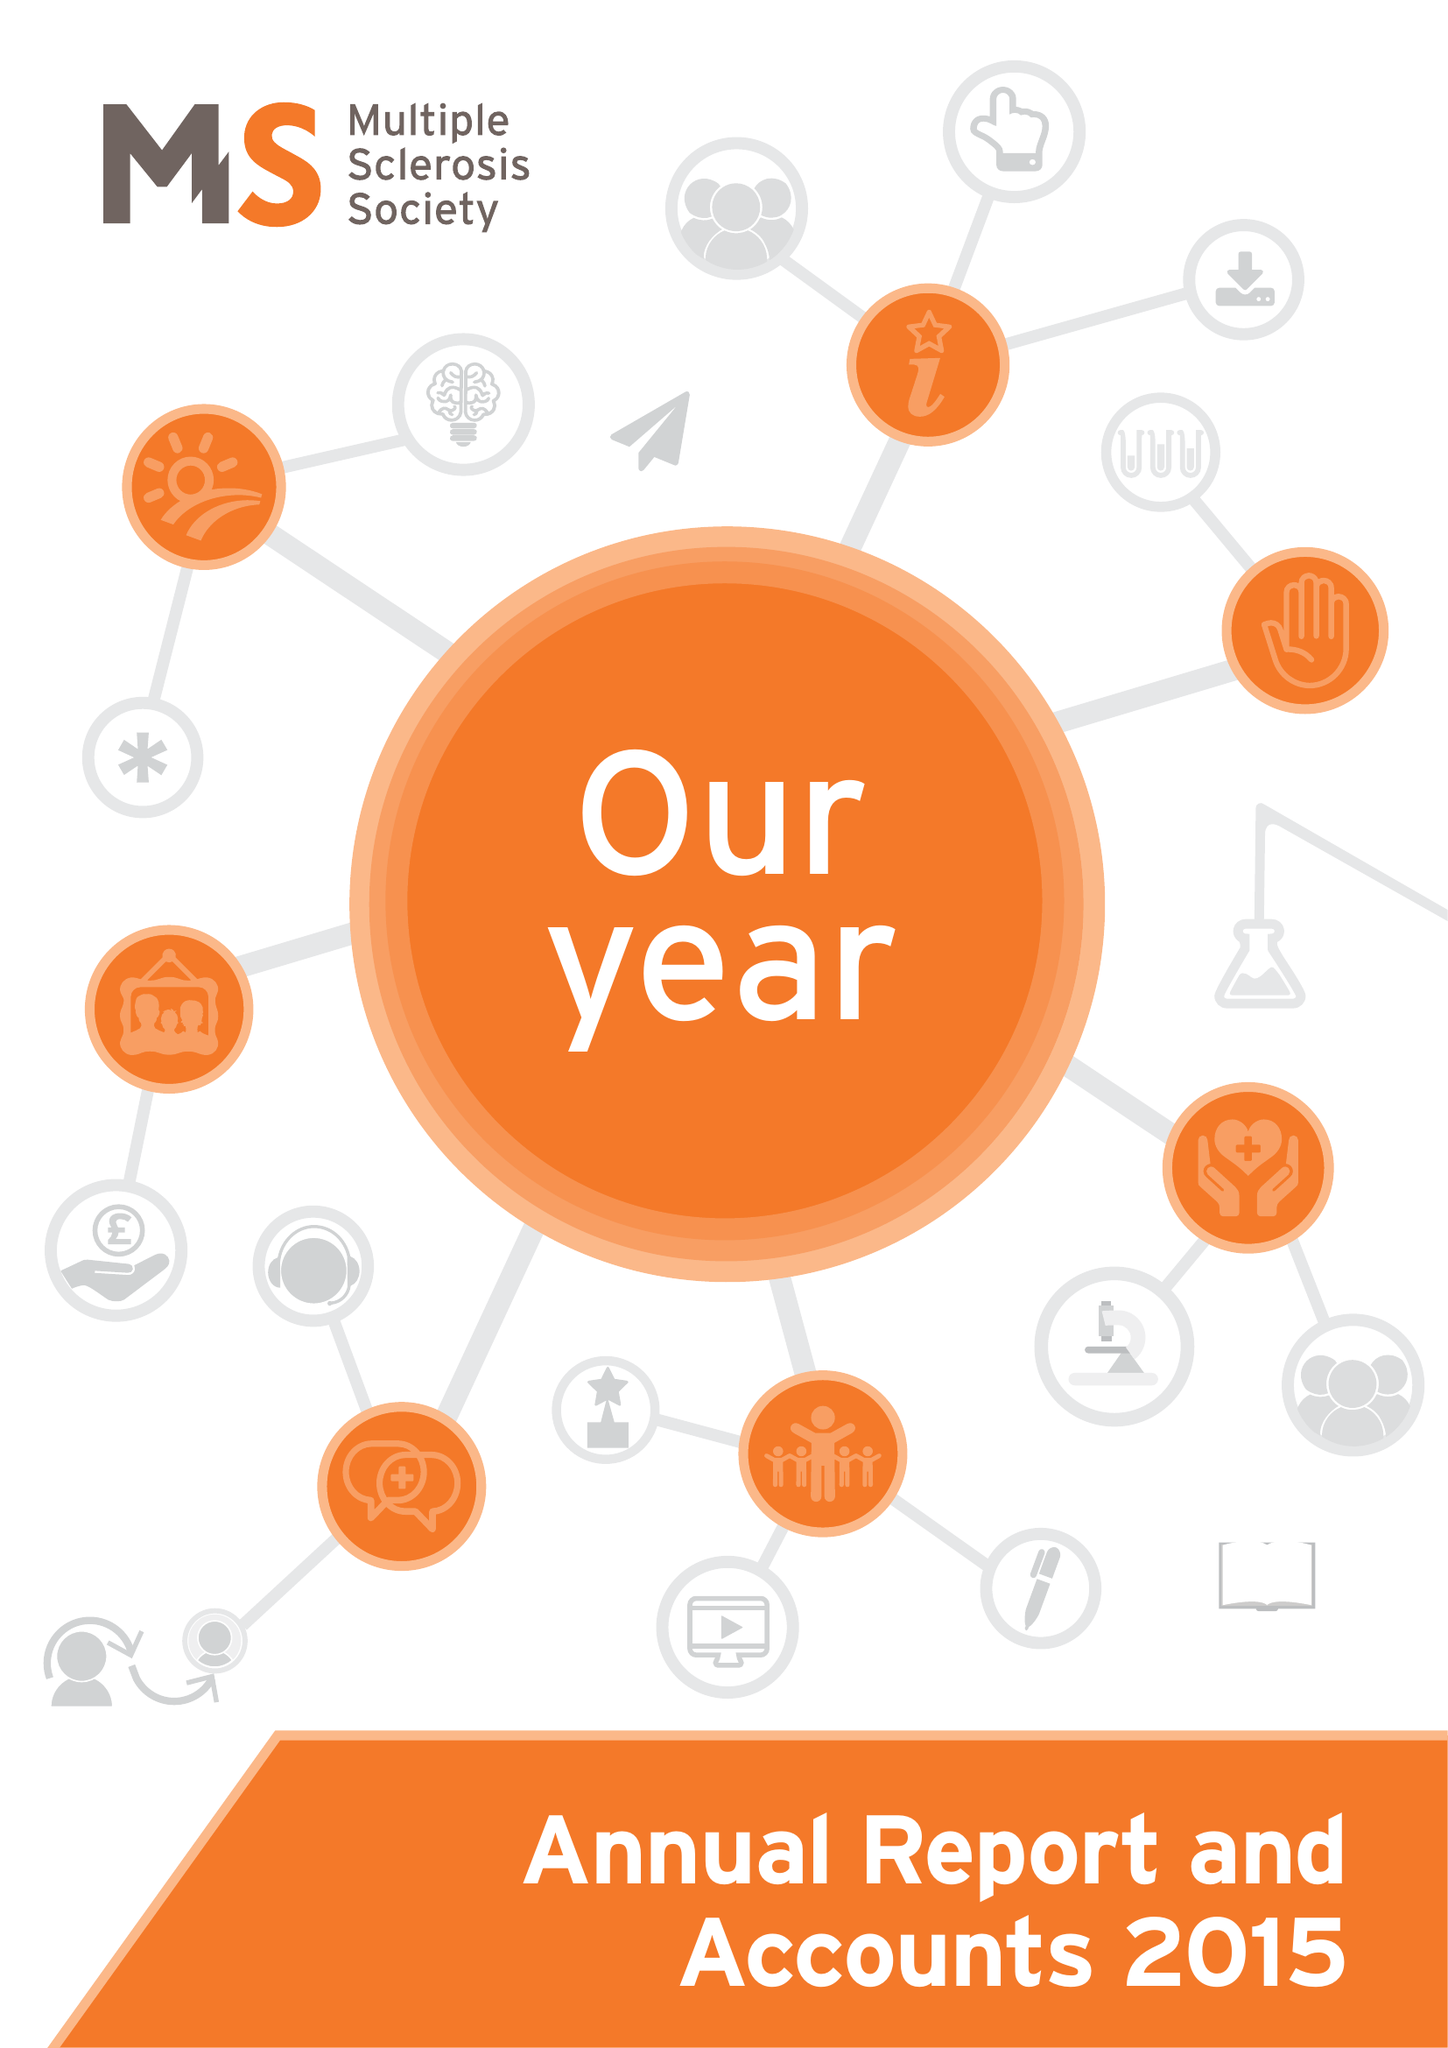What is the value for the charity_number?
Answer the question using a single word or phrase. 1139257 